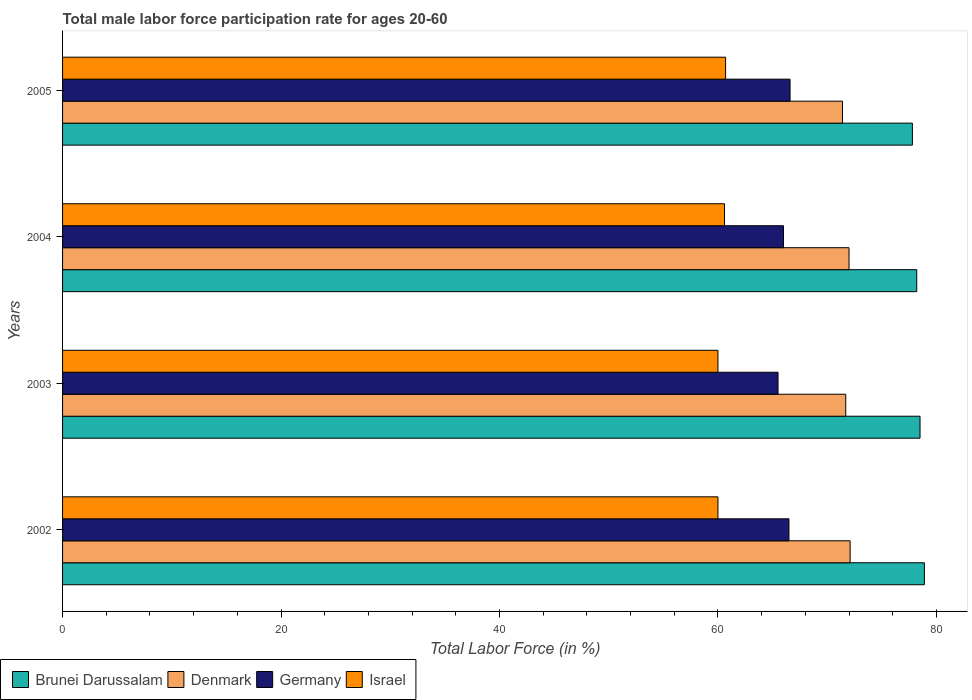How many different coloured bars are there?
Provide a succinct answer. 4. How many groups of bars are there?
Offer a terse response. 4. Are the number of bars per tick equal to the number of legend labels?
Give a very brief answer. Yes. How many bars are there on the 4th tick from the top?
Keep it short and to the point. 4. What is the label of the 3rd group of bars from the top?
Make the answer very short. 2003. What is the male labor force participation rate in Israel in 2005?
Give a very brief answer. 60.7. Across all years, what is the maximum male labor force participation rate in Brunei Darussalam?
Make the answer very short. 78.9. Across all years, what is the minimum male labor force participation rate in Israel?
Provide a succinct answer. 60. In which year was the male labor force participation rate in Israel maximum?
Provide a short and direct response. 2005. What is the total male labor force participation rate in Germany in the graph?
Offer a very short reply. 264.6. What is the difference between the male labor force participation rate in Brunei Darussalam in 2003 and that in 2004?
Provide a succinct answer. 0.3. What is the difference between the male labor force participation rate in Israel in 2004 and the male labor force participation rate in Germany in 2005?
Make the answer very short. -6. What is the average male labor force participation rate in Brunei Darussalam per year?
Offer a terse response. 78.35. In the year 2002, what is the difference between the male labor force participation rate in Israel and male labor force participation rate in Denmark?
Provide a succinct answer. -12.1. In how many years, is the male labor force participation rate in Germany greater than 48 %?
Provide a succinct answer. 4. What is the ratio of the male labor force participation rate in Israel in 2003 to that in 2004?
Offer a very short reply. 0.99. Is the difference between the male labor force participation rate in Israel in 2003 and 2005 greater than the difference between the male labor force participation rate in Denmark in 2003 and 2005?
Keep it short and to the point. No. What is the difference between the highest and the second highest male labor force participation rate in Israel?
Provide a succinct answer. 0.1. What is the difference between the highest and the lowest male labor force participation rate in Israel?
Keep it short and to the point. 0.7. In how many years, is the male labor force participation rate in Germany greater than the average male labor force participation rate in Germany taken over all years?
Make the answer very short. 2. Is the sum of the male labor force participation rate in Germany in 2004 and 2005 greater than the maximum male labor force participation rate in Israel across all years?
Keep it short and to the point. Yes. What does the 1st bar from the bottom in 2004 represents?
Provide a succinct answer. Brunei Darussalam. Is it the case that in every year, the sum of the male labor force participation rate in Denmark and male labor force participation rate in Brunei Darussalam is greater than the male labor force participation rate in Israel?
Provide a succinct answer. Yes. How many bars are there?
Offer a very short reply. 16. Does the graph contain any zero values?
Offer a terse response. No. Does the graph contain grids?
Make the answer very short. No. Where does the legend appear in the graph?
Make the answer very short. Bottom left. How many legend labels are there?
Ensure brevity in your answer.  4. What is the title of the graph?
Offer a terse response. Total male labor force participation rate for ages 20-60. Does "Middle East & North Africa (developing only)" appear as one of the legend labels in the graph?
Your answer should be compact. No. What is the label or title of the X-axis?
Give a very brief answer. Total Labor Force (in %). What is the label or title of the Y-axis?
Your answer should be very brief. Years. What is the Total Labor Force (in %) of Brunei Darussalam in 2002?
Provide a short and direct response. 78.9. What is the Total Labor Force (in %) of Denmark in 2002?
Offer a terse response. 72.1. What is the Total Labor Force (in %) of Germany in 2002?
Offer a terse response. 66.5. What is the Total Labor Force (in %) in Israel in 2002?
Provide a succinct answer. 60. What is the Total Labor Force (in %) in Brunei Darussalam in 2003?
Your answer should be very brief. 78.5. What is the Total Labor Force (in %) of Denmark in 2003?
Provide a succinct answer. 71.7. What is the Total Labor Force (in %) in Germany in 2003?
Give a very brief answer. 65.5. What is the Total Labor Force (in %) of Israel in 2003?
Provide a succinct answer. 60. What is the Total Labor Force (in %) of Brunei Darussalam in 2004?
Your answer should be compact. 78.2. What is the Total Labor Force (in %) of Germany in 2004?
Your answer should be very brief. 66. What is the Total Labor Force (in %) in Israel in 2004?
Your answer should be compact. 60.6. What is the Total Labor Force (in %) in Brunei Darussalam in 2005?
Your answer should be compact. 77.8. What is the Total Labor Force (in %) of Denmark in 2005?
Offer a terse response. 71.4. What is the Total Labor Force (in %) of Germany in 2005?
Your answer should be very brief. 66.6. What is the Total Labor Force (in %) of Israel in 2005?
Your response must be concise. 60.7. Across all years, what is the maximum Total Labor Force (in %) of Brunei Darussalam?
Give a very brief answer. 78.9. Across all years, what is the maximum Total Labor Force (in %) in Denmark?
Your response must be concise. 72.1. Across all years, what is the maximum Total Labor Force (in %) in Germany?
Give a very brief answer. 66.6. Across all years, what is the maximum Total Labor Force (in %) of Israel?
Provide a short and direct response. 60.7. Across all years, what is the minimum Total Labor Force (in %) of Brunei Darussalam?
Keep it short and to the point. 77.8. Across all years, what is the minimum Total Labor Force (in %) of Denmark?
Keep it short and to the point. 71.4. Across all years, what is the minimum Total Labor Force (in %) in Germany?
Offer a very short reply. 65.5. What is the total Total Labor Force (in %) of Brunei Darussalam in the graph?
Make the answer very short. 313.4. What is the total Total Labor Force (in %) in Denmark in the graph?
Ensure brevity in your answer.  287.2. What is the total Total Labor Force (in %) in Germany in the graph?
Offer a terse response. 264.6. What is the total Total Labor Force (in %) of Israel in the graph?
Your answer should be very brief. 241.3. What is the difference between the Total Labor Force (in %) in Denmark in 2002 and that in 2003?
Your response must be concise. 0.4. What is the difference between the Total Labor Force (in %) in Germany in 2002 and that in 2003?
Your response must be concise. 1. What is the difference between the Total Labor Force (in %) in Israel in 2002 and that in 2003?
Give a very brief answer. 0. What is the difference between the Total Labor Force (in %) in Denmark in 2002 and that in 2004?
Your response must be concise. 0.1. What is the difference between the Total Labor Force (in %) in Israel in 2002 and that in 2004?
Your response must be concise. -0.6. What is the difference between the Total Labor Force (in %) in Brunei Darussalam in 2002 and that in 2005?
Offer a very short reply. 1.1. What is the difference between the Total Labor Force (in %) of Denmark in 2002 and that in 2005?
Offer a very short reply. 0.7. What is the difference between the Total Labor Force (in %) in Israel in 2002 and that in 2005?
Ensure brevity in your answer.  -0.7. What is the difference between the Total Labor Force (in %) of Brunei Darussalam in 2003 and that in 2004?
Offer a terse response. 0.3. What is the difference between the Total Labor Force (in %) of Denmark in 2003 and that in 2004?
Offer a terse response. -0.3. What is the difference between the Total Labor Force (in %) in Israel in 2003 and that in 2004?
Offer a terse response. -0.6. What is the difference between the Total Labor Force (in %) in Denmark in 2003 and that in 2005?
Your answer should be very brief. 0.3. What is the difference between the Total Labor Force (in %) in Brunei Darussalam in 2004 and that in 2005?
Give a very brief answer. 0.4. What is the difference between the Total Labor Force (in %) in Denmark in 2004 and that in 2005?
Ensure brevity in your answer.  0.6. What is the difference between the Total Labor Force (in %) of Germany in 2004 and that in 2005?
Make the answer very short. -0.6. What is the difference between the Total Labor Force (in %) in Brunei Darussalam in 2002 and the Total Labor Force (in %) in Germany in 2003?
Provide a succinct answer. 13.4. What is the difference between the Total Labor Force (in %) of Denmark in 2002 and the Total Labor Force (in %) of Israel in 2003?
Your answer should be very brief. 12.1. What is the difference between the Total Labor Force (in %) in Brunei Darussalam in 2002 and the Total Labor Force (in %) in Denmark in 2004?
Your response must be concise. 6.9. What is the difference between the Total Labor Force (in %) in Brunei Darussalam in 2002 and the Total Labor Force (in %) in Germany in 2004?
Your answer should be compact. 12.9. What is the difference between the Total Labor Force (in %) of Brunei Darussalam in 2002 and the Total Labor Force (in %) of Israel in 2004?
Give a very brief answer. 18.3. What is the difference between the Total Labor Force (in %) of Germany in 2002 and the Total Labor Force (in %) of Israel in 2004?
Ensure brevity in your answer.  5.9. What is the difference between the Total Labor Force (in %) in Brunei Darussalam in 2002 and the Total Labor Force (in %) in Germany in 2005?
Offer a very short reply. 12.3. What is the difference between the Total Labor Force (in %) in Brunei Darussalam in 2002 and the Total Labor Force (in %) in Israel in 2005?
Make the answer very short. 18.2. What is the difference between the Total Labor Force (in %) in Denmark in 2002 and the Total Labor Force (in %) in Germany in 2005?
Offer a very short reply. 5.5. What is the difference between the Total Labor Force (in %) in Denmark in 2002 and the Total Labor Force (in %) in Israel in 2005?
Your answer should be very brief. 11.4. What is the difference between the Total Labor Force (in %) of Germany in 2002 and the Total Labor Force (in %) of Israel in 2005?
Your response must be concise. 5.8. What is the difference between the Total Labor Force (in %) in Brunei Darussalam in 2003 and the Total Labor Force (in %) in Germany in 2004?
Your response must be concise. 12.5. What is the difference between the Total Labor Force (in %) of Brunei Darussalam in 2003 and the Total Labor Force (in %) of Israel in 2004?
Offer a very short reply. 17.9. What is the difference between the Total Labor Force (in %) in Denmark in 2003 and the Total Labor Force (in %) in Germany in 2004?
Your answer should be compact. 5.7. What is the difference between the Total Labor Force (in %) of Denmark in 2003 and the Total Labor Force (in %) of Israel in 2004?
Offer a very short reply. 11.1. What is the difference between the Total Labor Force (in %) of Brunei Darussalam in 2003 and the Total Labor Force (in %) of Denmark in 2005?
Your response must be concise. 7.1. What is the difference between the Total Labor Force (in %) of Brunei Darussalam in 2003 and the Total Labor Force (in %) of Germany in 2005?
Offer a very short reply. 11.9. What is the difference between the Total Labor Force (in %) of Brunei Darussalam in 2004 and the Total Labor Force (in %) of Germany in 2005?
Offer a terse response. 11.6. What is the difference between the Total Labor Force (in %) in Germany in 2004 and the Total Labor Force (in %) in Israel in 2005?
Make the answer very short. 5.3. What is the average Total Labor Force (in %) in Brunei Darussalam per year?
Your response must be concise. 78.35. What is the average Total Labor Force (in %) of Denmark per year?
Provide a short and direct response. 71.8. What is the average Total Labor Force (in %) in Germany per year?
Your answer should be compact. 66.15. What is the average Total Labor Force (in %) in Israel per year?
Your response must be concise. 60.33. In the year 2002, what is the difference between the Total Labor Force (in %) in Denmark and Total Labor Force (in %) in Israel?
Offer a terse response. 12.1. In the year 2003, what is the difference between the Total Labor Force (in %) in Brunei Darussalam and Total Labor Force (in %) in Germany?
Give a very brief answer. 13. In the year 2003, what is the difference between the Total Labor Force (in %) in Denmark and Total Labor Force (in %) in Germany?
Make the answer very short. 6.2. In the year 2003, what is the difference between the Total Labor Force (in %) in Denmark and Total Labor Force (in %) in Israel?
Give a very brief answer. 11.7. In the year 2004, what is the difference between the Total Labor Force (in %) in Brunei Darussalam and Total Labor Force (in %) in Germany?
Offer a very short reply. 12.2. In the year 2004, what is the difference between the Total Labor Force (in %) of Denmark and Total Labor Force (in %) of Israel?
Provide a succinct answer. 11.4. In the year 2004, what is the difference between the Total Labor Force (in %) in Germany and Total Labor Force (in %) in Israel?
Keep it short and to the point. 5.4. In the year 2005, what is the difference between the Total Labor Force (in %) in Brunei Darussalam and Total Labor Force (in %) in Germany?
Provide a succinct answer. 11.2. In the year 2005, what is the difference between the Total Labor Force (in %) of Brunei Darussalam and Total Labor Force (in %) of Israel?
Your answer should be compact. 17.1. In the year 2005, what is the difference between the Total Labor Force (in %) of Denmark and Total Labor Force (in %) of Israel?
Offer a terse response. 10.7. In the year 2005, what is the difference between the Total Labor Force (in %) in Germany and Total Labor Force (in %) in Israel?
Provide a succinct answer. 5.9. What is the ratio of the Total Labor Force (in %) in Brunei Darussalam in 2002 to that in 2003?
Give a very brief answer. 1.01. What is the ratio of the Total Labor Force (in %) in Denmark in 2002 to that in 2003?
Keep it short and to the point. 1.01. What is the ratio of the Total Labor Force (in %) in Germany in 2002 to that in 2003?
Your answer should be very brief. 1.02. What is the ratio of the Total Labor Force (in %) in Israel in 2002 to that in 2003?
Provide a succinct answer. 1. What is the ratio of the Total Labor Force (in %) in Brunei Darussalam in 2002 to that in 2004?
Offer a very short reply. 1.01. What is the ratio of the Total Labor Force (in %) in Denmark in 2002 to that in 2004?
Make the answer very short. 1. What is the ratio of the Total Labor Force (in %) in Germany in 2002 to that in 2004?
Ensure brevity in your answer.  1.01. What is the ratio of the Total Labor Force (in %) of Israel in 2002 to that in 2004?
Give a very brief answer. 0.99. What is the ratio of the Total Labor Force (in %) of Brunei Darussalam in 2002 to that in 2005?
Provide a succinct answer. 1.01. What is the ratio of the Total Labor Force (in %) in Denmark in 2002 to that in 2005?
Offer a terse response. 1.01. What is the ratio of the Total Labor Force (in %) in Israel in 2002 to that in 2005?
Make the answer very short. 0.99. What is the ratio of the Total Labor Force (in %) of Germany in 2003 to that in 2005?
Ensure brevity in your answer.  0.98. What is the ratio of the Total Labor Force (in %) in Denmark in 2004 to that in 2005?
Your answer should be very brief. 1.01. What is the ratio of the Total Labor Force (in %) in Germany in 2004 to that in 2005?
Your answer should be very brief. 0.99. What is the difference between the highest and the second highest Total Labor Force (in %) of Brunei Darussalam?
Offer a terse response. 0.4. What is the difference between the highest and the second highest Total Labor Force (in %) in Germany?
Your answer should be very brief. 0.1. What is the difference between the highest and the second highest Total Labor Force (in %) in Israel?
Your answer should be very brief. 0.1. What is the difference between the highest and the lowest Total Labor Force (in %) in Germany?
Give a very brief answer. 1.1. What is the difference between the highest and the lowest Total Labor Force (in %) of Israel?
Your answer should be compact. 0.7. 